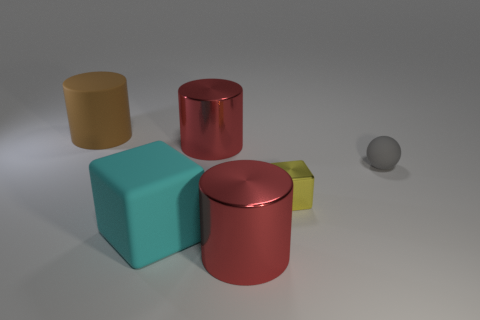Add 1 tiny green shiny blocks. How many objects exist? 7 Subtract all spheres. How many objects are left? 5 Add 3 tiny rubber spheres. How many tiny rubber spheres are left? 4 Add 4 blocks. How many blocks exist? 6 Subtract 0 purple cylinders. How many objects are left? 6 Subtract all blue rubber objects. Subtract all metal cylinders. How many objects are left? 4 